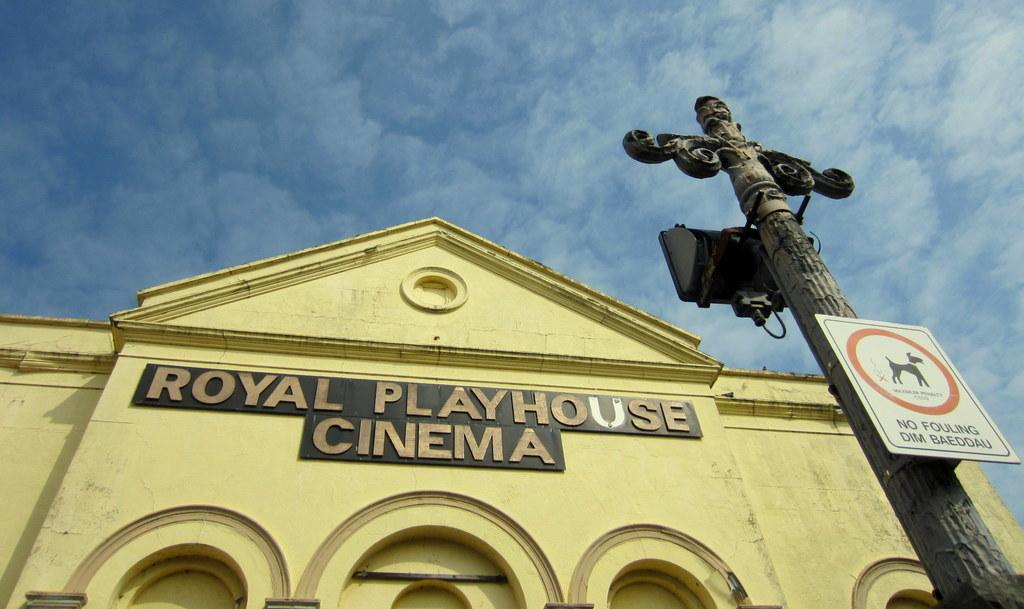<image>
Offer a succinct explanation of the picture presented. The Royal Playhouse Cinema and some of the sky. 